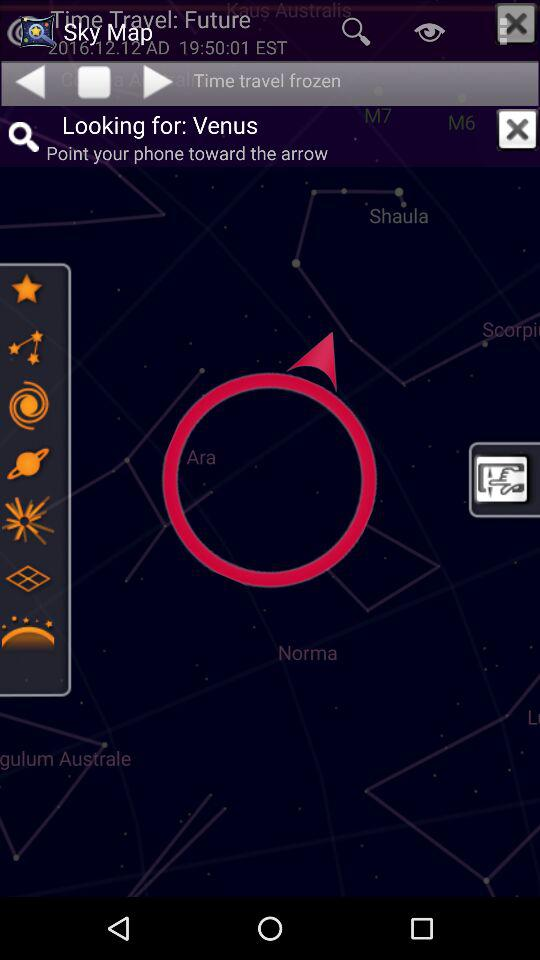Where is Venus?
When the provided information is insufficient, respond with <no answer>. <no answer> 